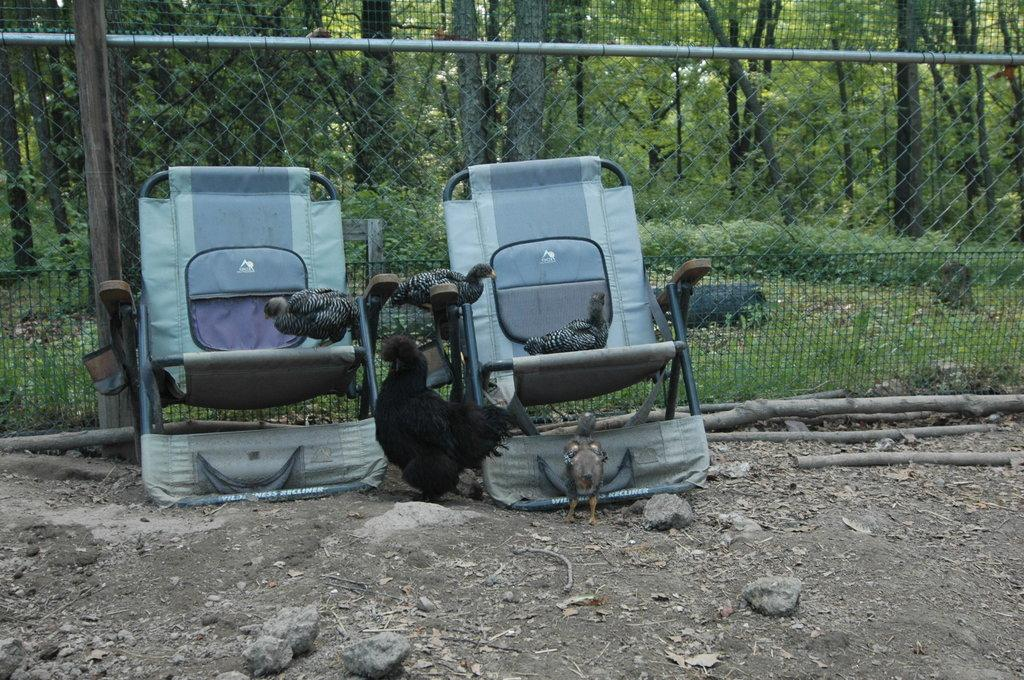How many chairs are visible in the image? There are two chairs in the image. What type of animals can be seen in the image? There are hens in the image. What is present at the bottom of the image? There are stones at the bottom of the image. What can be seen in the background of the image? There is fencing and trees in the background of the image. What else is present in the image besides the chairs and hens? There are bamboo sticks in the image. What type of wrench is being used to repair the structure in the image? There is no wrench or structure present in the image. What sign can be seen in the image? There is no sign present in the image. 